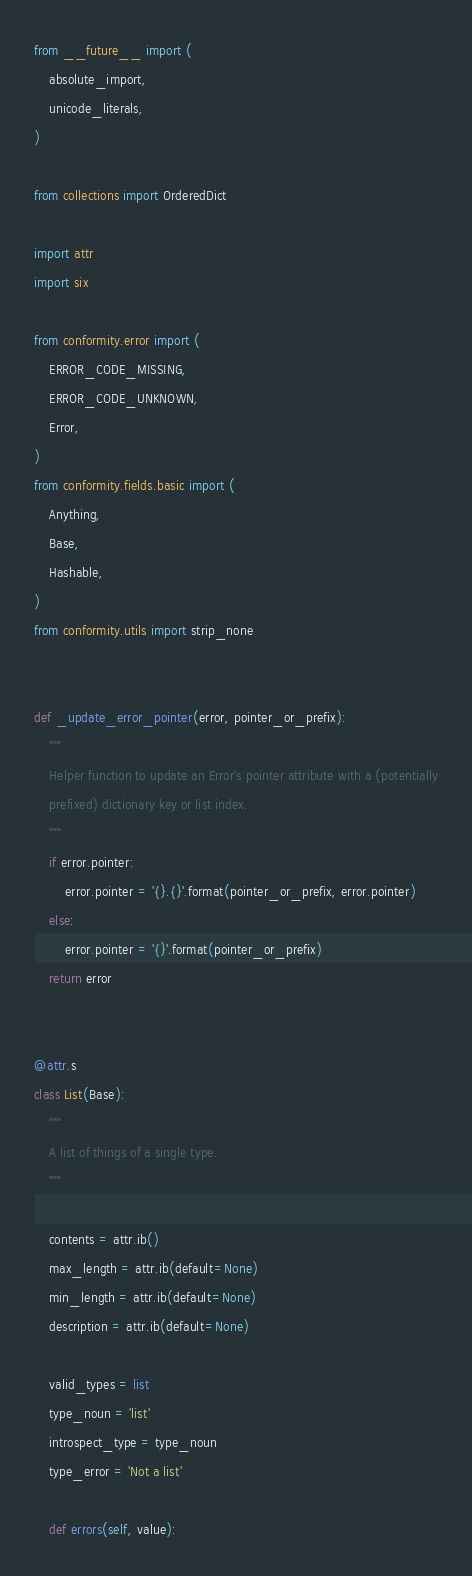<code> <loc_0><loc_0><loc_500><loc_500><_Python_>from __future__ import (
    absolute_import,
    unicode_literals,
)

from collections import OrderedDict

import attr
import six

from conformity.error import (
    ERROR_CODE_MISSING,
    ERROR_CODE_UNKNOWN,
    Error,
)
from conformity.fields.basic import (
    Anything,
    Base,
    Hashable,
)
from conformity.utils import strip_none


def _update_error_pointer(error, pointer_or_prefix):
    """
    Helper function to update an Error's pointer attribute with a (potentially
    prefixed) dictionary key or list index.
    """
    if error.pointer:
        error.pointer = '{}.{}'.format(pointer_or_prefix, error.pointer)
    else:
        error.pointer = '{}'.format(pointer_or_prefix)
    return error


@attr.s
class List(Base):
    """
    A list of things of a single type.
    """

    contents = attr.ib()
    max_length = attr.ib(default=None)
    min_length = attr.ib(default=None)
    description = attr.ib(default=None)

    valid_types = list
    type_noun = 'list'
    introspect_type = type_noun
    type_error = 'Not a list'

    def errors(self, value):</code> 